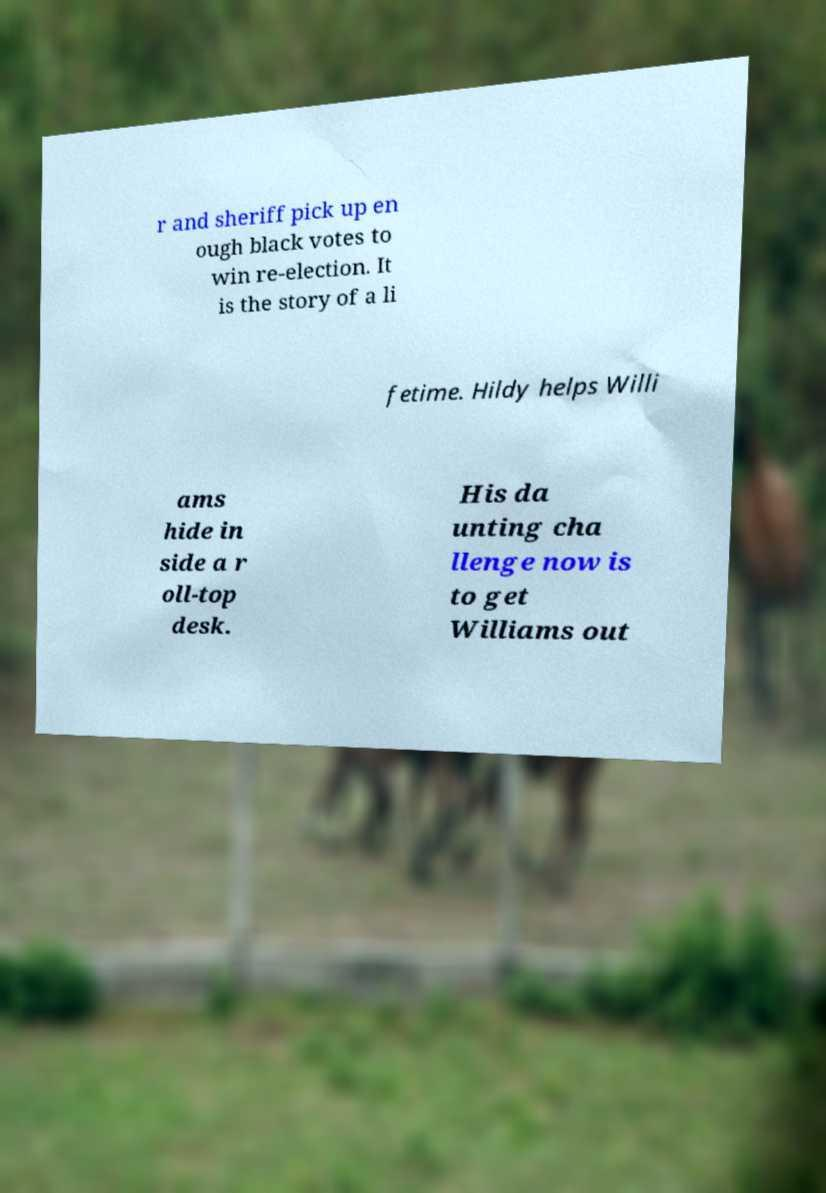I need the written content from this picture converted into text. Can you do that? r and sheriff pick up en ough black votes to win re-election. It is the story of a li fetime. Hildy helps Willi ams hide in side a r oll-top desk. His da unting cha llenge now is to get Williams out 